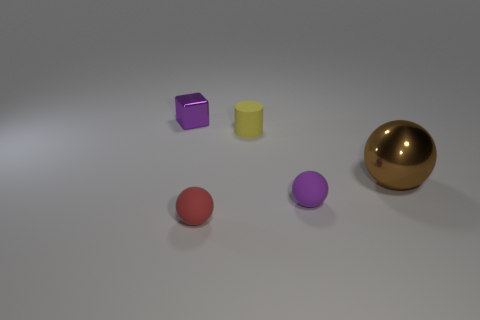Add 3 big green matte objects. How many objects exist? 8 Subtract all cylinders. How many objects are left? 4 Add 4 small red spheres. How many small red spheres are left? 5 Add 2 matte cylinders. How many matte cylinders exist? 3 Subtract 0 gray balls. How many objects are left? 5 Subtract all purple rubber balls. Subtract all small red things. How many objects are left? 3 